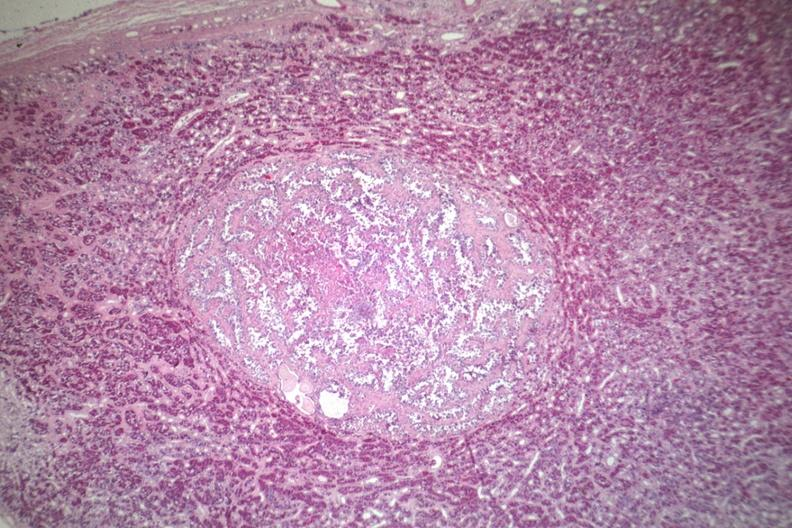s endocrine present?
Answer the question using a single word or phrase. Yes 